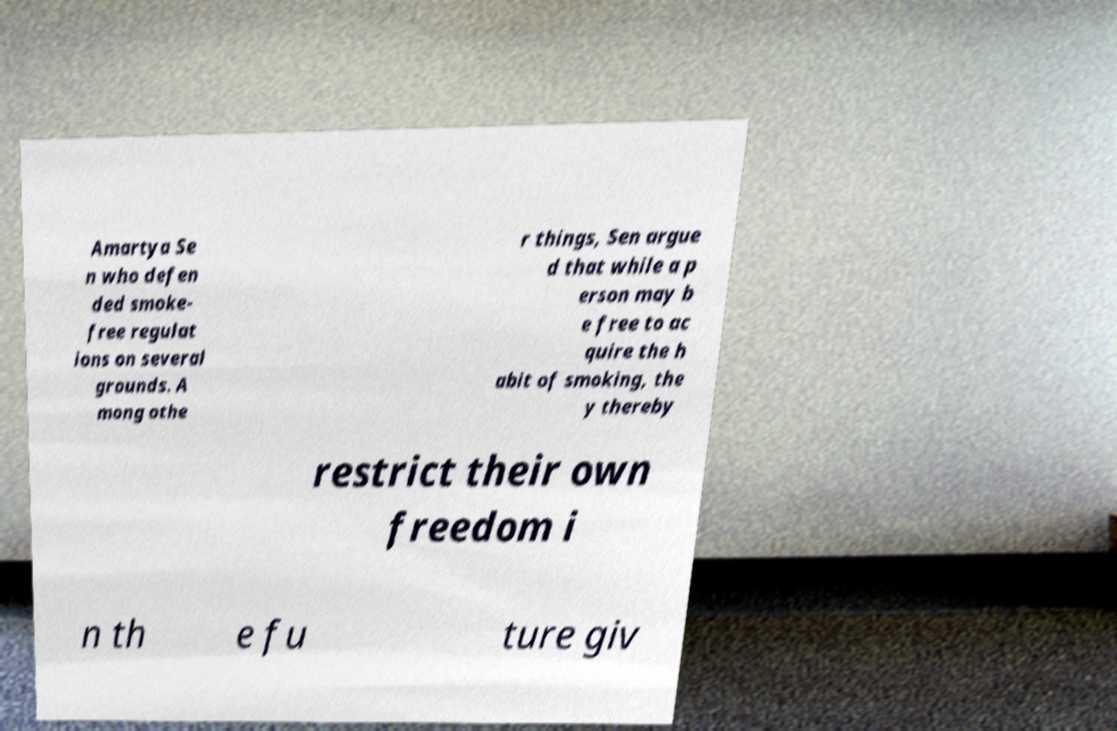There's text embedded in this image that I need extracted. Can you transcribe it verbatim? Amartya Se n who defen ded smoke- free regulat ions on several grounds. A mong othe r things, Sen argue d that while a p erson may b e free to ac quire the h abit of smoking, the y thereby restrict their own freedom i n th e fu ture giv 